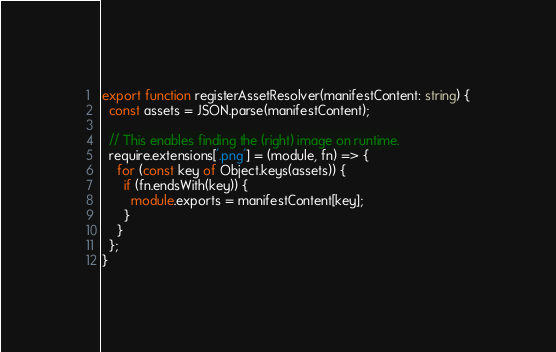<code> <loc_0><loc_0><loc_500><loc_500><_TypeScript_>
export function registerAssetResolver(manifestContent: string) {
  const assets = JSON.parse(manifestContent);

  // This enables finding the (right) image on runtime.
  require.extensions['.png'] = (module, fn) => {
    for (const key of Object.keys(assets)) {
      if (fn.endsWith(key)) {
        module.exports = manifestContent[key];
      }
    }
  };
}
</code> 